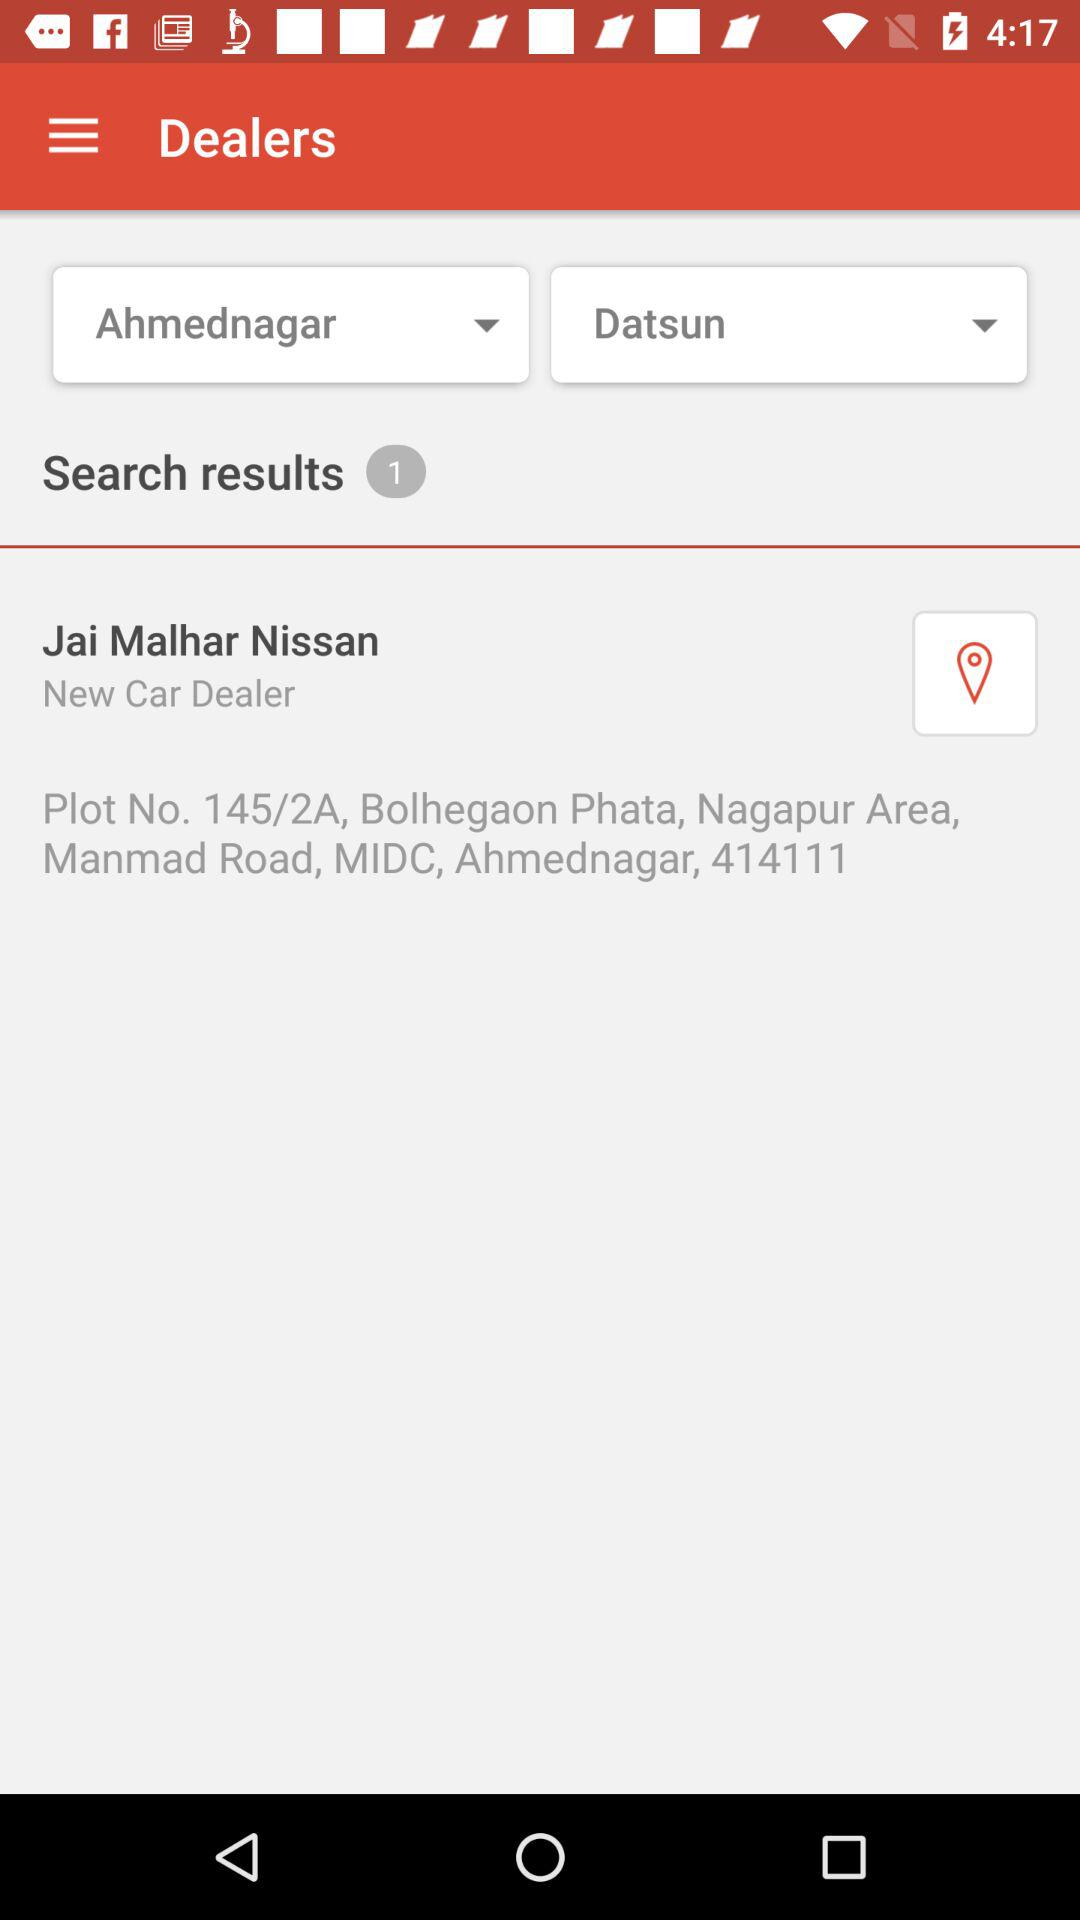What is the location of "Jai Malhar Nissan"? The location of "Jai Malhar Nissan" is Plot No. 145/2A, Bolhegaon Phata, Nagapur Area, Manmad Road, MIDC, Ahmednagar, 414111. 